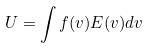<formula> <loc_0><loc_0><loc_500><loc_500>U = \int f ( v ) E ( v ) d v</formula> 